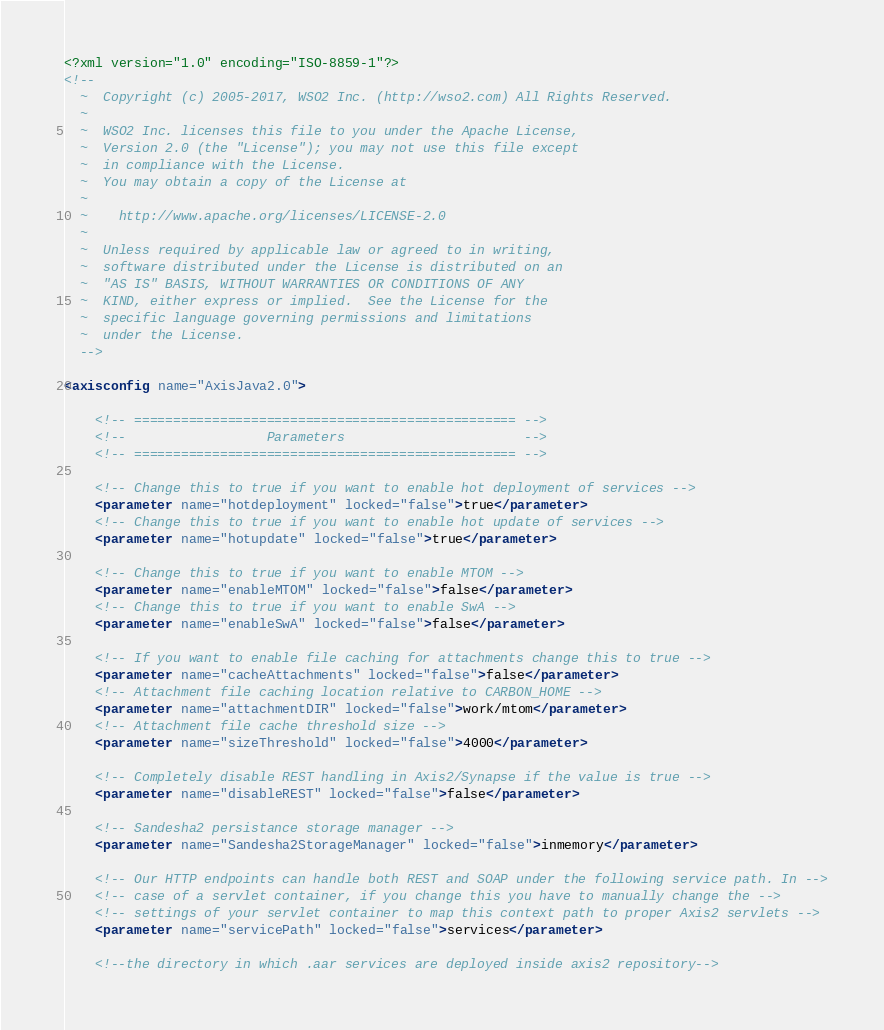<code> <loc_0><loc_0><loc_500><loc_500><_XML_><?xml version="1.0" encoding="ISO-8859-1"?>
<!--
  ~  Copyright (c) 2005-2017, WSO2 Inc. (http://wso2.com) All Rights Reserved.
  ~
  ~  WSO2 Inc. licenses this file to you under the Apache License,
  ~  Version 2.0 (the "License"); you may not use this file except
  ~  in compliance with the License.
  ~  You may obtain a copy of the License at
  ~
  ~    http://www.apache.org/licenses/LICENSE-2.0
  ~
  ~  Unless required by applicable law or agreed to in writing,
  ~  software distributed under the License is distributed on an
  ~  "AS IS" BASIS, WITHOUT WARRANTIES OR CONDITIONS OF ANY
  ~  KIND, either express or implied.  See the License for the
  ~  specific language governing permissions and limitations
  ~  under the License.
  -->

<axisconfig name="AxisJava2.0">

    <!-- ================================================= -->
    <!--                  Parameters                       -->
    <!-- ================================================= -->

    <!-- Change this to true if you want to enable hot deployment of services -->
    <parameter name="hotdeployment" locked="false">true</parameter>
    <!-- Change this to true if you want to enable hot update of services -->
    <parameter name="hotupdate" locked="false">true</parameter>

    <!-- Change this to true if you want to enable MTOM -->
    <parameter name="enableMTOM" locked="false">false</parameter>
    <!-- Change this to true if you want to enable SwA -->
    <parameter name="enableSwA" locked="false">false</parameter>

    <!-- If you want to enable file caching for attachments change this to true -->
    <parameter name="cacheAttachments" locked="false">false</parameter>
    <!-- Attachment file caching location relative to CARBON_HOME -->
    <parameter name="attachmentDIR" locked="false">work/mtom</parameter>
    <!-- Attachment file cache threshold size -->
    <parameter name="sizeThreshold" locked="false">4000</parameter>

    <!-- Completely disable REST handling in Axis2/Synapse if the value is true -->
    <parameter name="disableREST" locked="false">false</parameter>

    <!-- Sandesha2 persistance storage manager -->
    <parameter name="Sandesha2StorageManager" locked="false">inmemory</parameter>

    <!-- Our HTTP endpoints can handle both REST and SOAP under the following service path. In -->
    <!-- case of a servlet container, if you change this you have to manually change the -->
    <!-- settings of your servlet container to map this context path to proper Axis2 servlets -->
    <parameter name="servicePath" locked="false">services</parameter>

    <!--the directory in which .aar services are deployed inside axis2 repository--></code> 